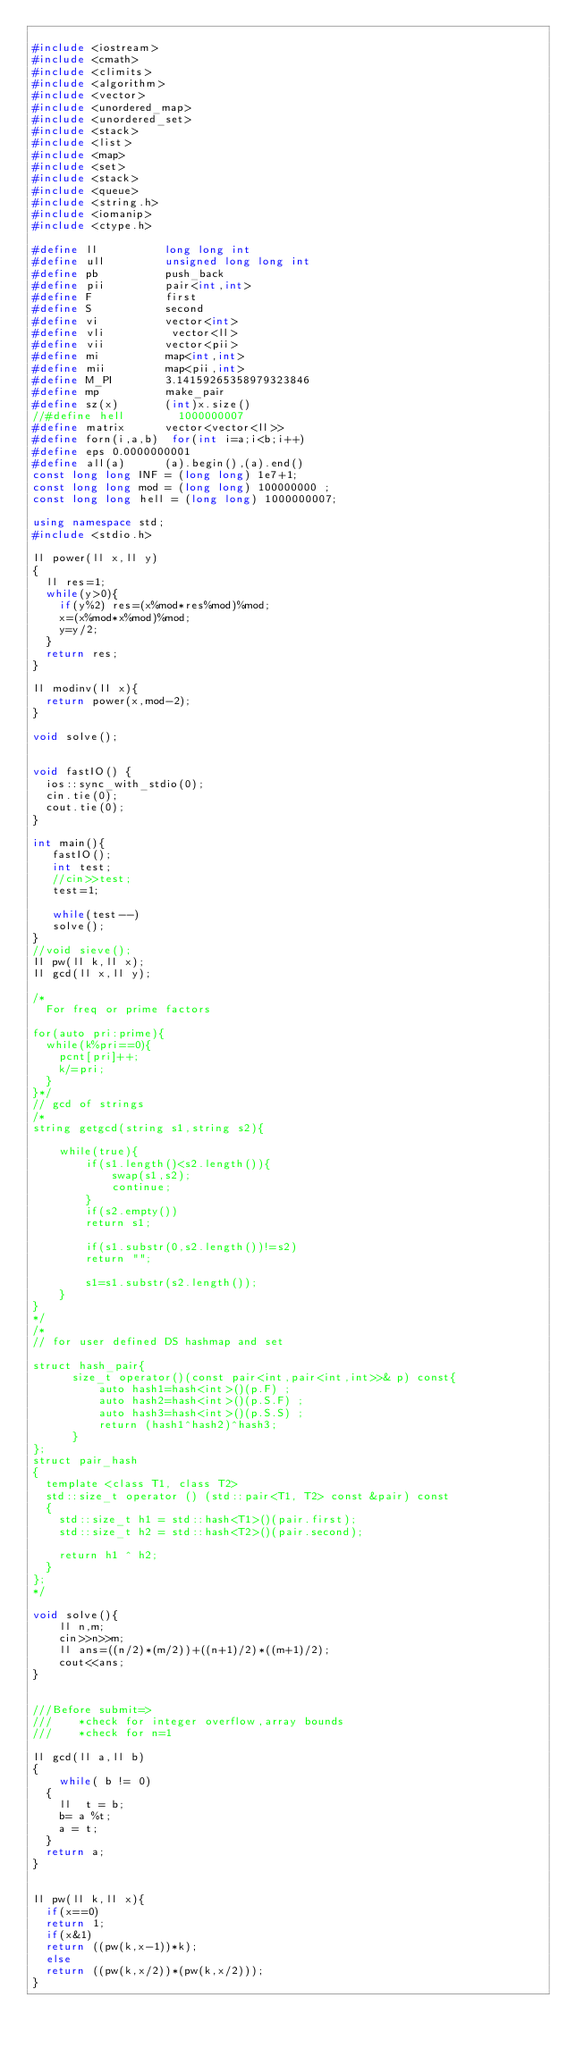<code> <loc_0><loc_0><loc_500><loc_500><_C++_>
#include <iostream>
#include <cmath>
#include <climits>
#include <algorithm>
#include <vector>
#include <unordered_map>
#include <unordered_set>
#include <stack>
#include <list>
#include <map>
#include <set>
#include <stack>
#include <queue>
#include <string.h>
#include <iomanip>
#include <ctype.h>

#define ll          long long int
#define ull         unsigned long long int
#define pb          push_back
#define pii         pair<int,int>
#define F           first
#define S           second
#define vi          vector<int>
#define vli          vector<ll>
#define vii         vector<pii>
#define mi          map<int,int>
#define mii         map<pii,int>
#define M_PI        3.14159265358979323846
#define mp          make_pair
#define sz(x)       (int)x.size()
//#define hell        1000000007
#define matrix      vector<vector<ll>>
#define forn(i,a,b)  for(int i=a;i<b;i++)
#define eps 0.0000000001
#define all(a)      (a).begin(),(a).end()
const long long INF = (long long) 1e7+1;
const long long mod = (long long) 100000000 ;
const long long hell = (long long) 1000000007;

using namespace std;
#include <stdio.h>

ll power(ll x,ll y)
{
  ll res=1;
  while(y>0){
    if(y%2) res=(x%mod*res%mod)%mod;
    x=(x%mod*x%mod)%mod;
    y=y/2;
  }
  return res;
}

ll modinv(ll x){
  return power(x,mod-2);
}

void solve();


void fastIO() {
  ios::sync_with_stdio(0);
  cin.tie(0);
  cout.tie(0);
}

int main(){
   fastIO();
   int test;
   //cin>>test;
   test=1;
   
   while(test--)
   solve();
}
//void sieve();
ll pw(ll k,ll x);
ll gcd(ll x,ll y);

/*
  For freq or prime factors

for(auto pri:prime){
  while(k%pri==0){
    pcnt[pri]++;
    k/=pri;
  }
}*/
// gcd of strings
/*
string getgcd(string s1,string s2){
    
    while(true){
        if(s1.length()<s2.length()){
            swap(s1,s2);
            continue;
        }
        if(s2.empty())
        return s1;
        
        if(s1.substr(0,s2.length())!=s2)
        return "";
        
        s1=s1.substr(s2.length());
    }
}
*/
/*
// for user defined DS hashmap and set
 
struct hash_pair{
      size_t operator()(const pair<int,pair<int,int>>& p) const{
          auto hash1=hash<int>()(p.F) ;
          auto hash2=hash<int>()(p.S.F) ;
          auto hash3=hash<int>()(p.S.S) ;
          return (hash1^hash2)^hash3;
      }  
};
struct pair_hash
{
	template <class T1, class T2>
	std::size_t operator () (std::pair<T1, T2> const &pair) const
	{
		std::size_t h1 = std::hash<T1>()(pair.first);
		std::size_t h2 = std::hash<T2>()(pair.second);

		return h1 ^ h2;
	}
};
*/

void solve(){
    ll n,m;
    cin>>n>>m;
    ll ans=((n/2)*(m/2))+((n+1)/2)*((m+1)/2);
    cout<<ans;
}    


///Before submit=>
///    *check for integer overflow,array bounds
///    *check for n=1

ll gcd(ll a,ll b)
{
    while( b != 0)
	{
		ll  t = b;
		b= a %t;
		a = t;
	}
	return a;
}


ll pw(ll k,ll x){
  if(x==0)
  return 1;
  if(x&1)
  return ((pw(k,x-1))*k);
  else
  return ((pw(k,x/2))*(pw(k,x/2)));
}



</code> 